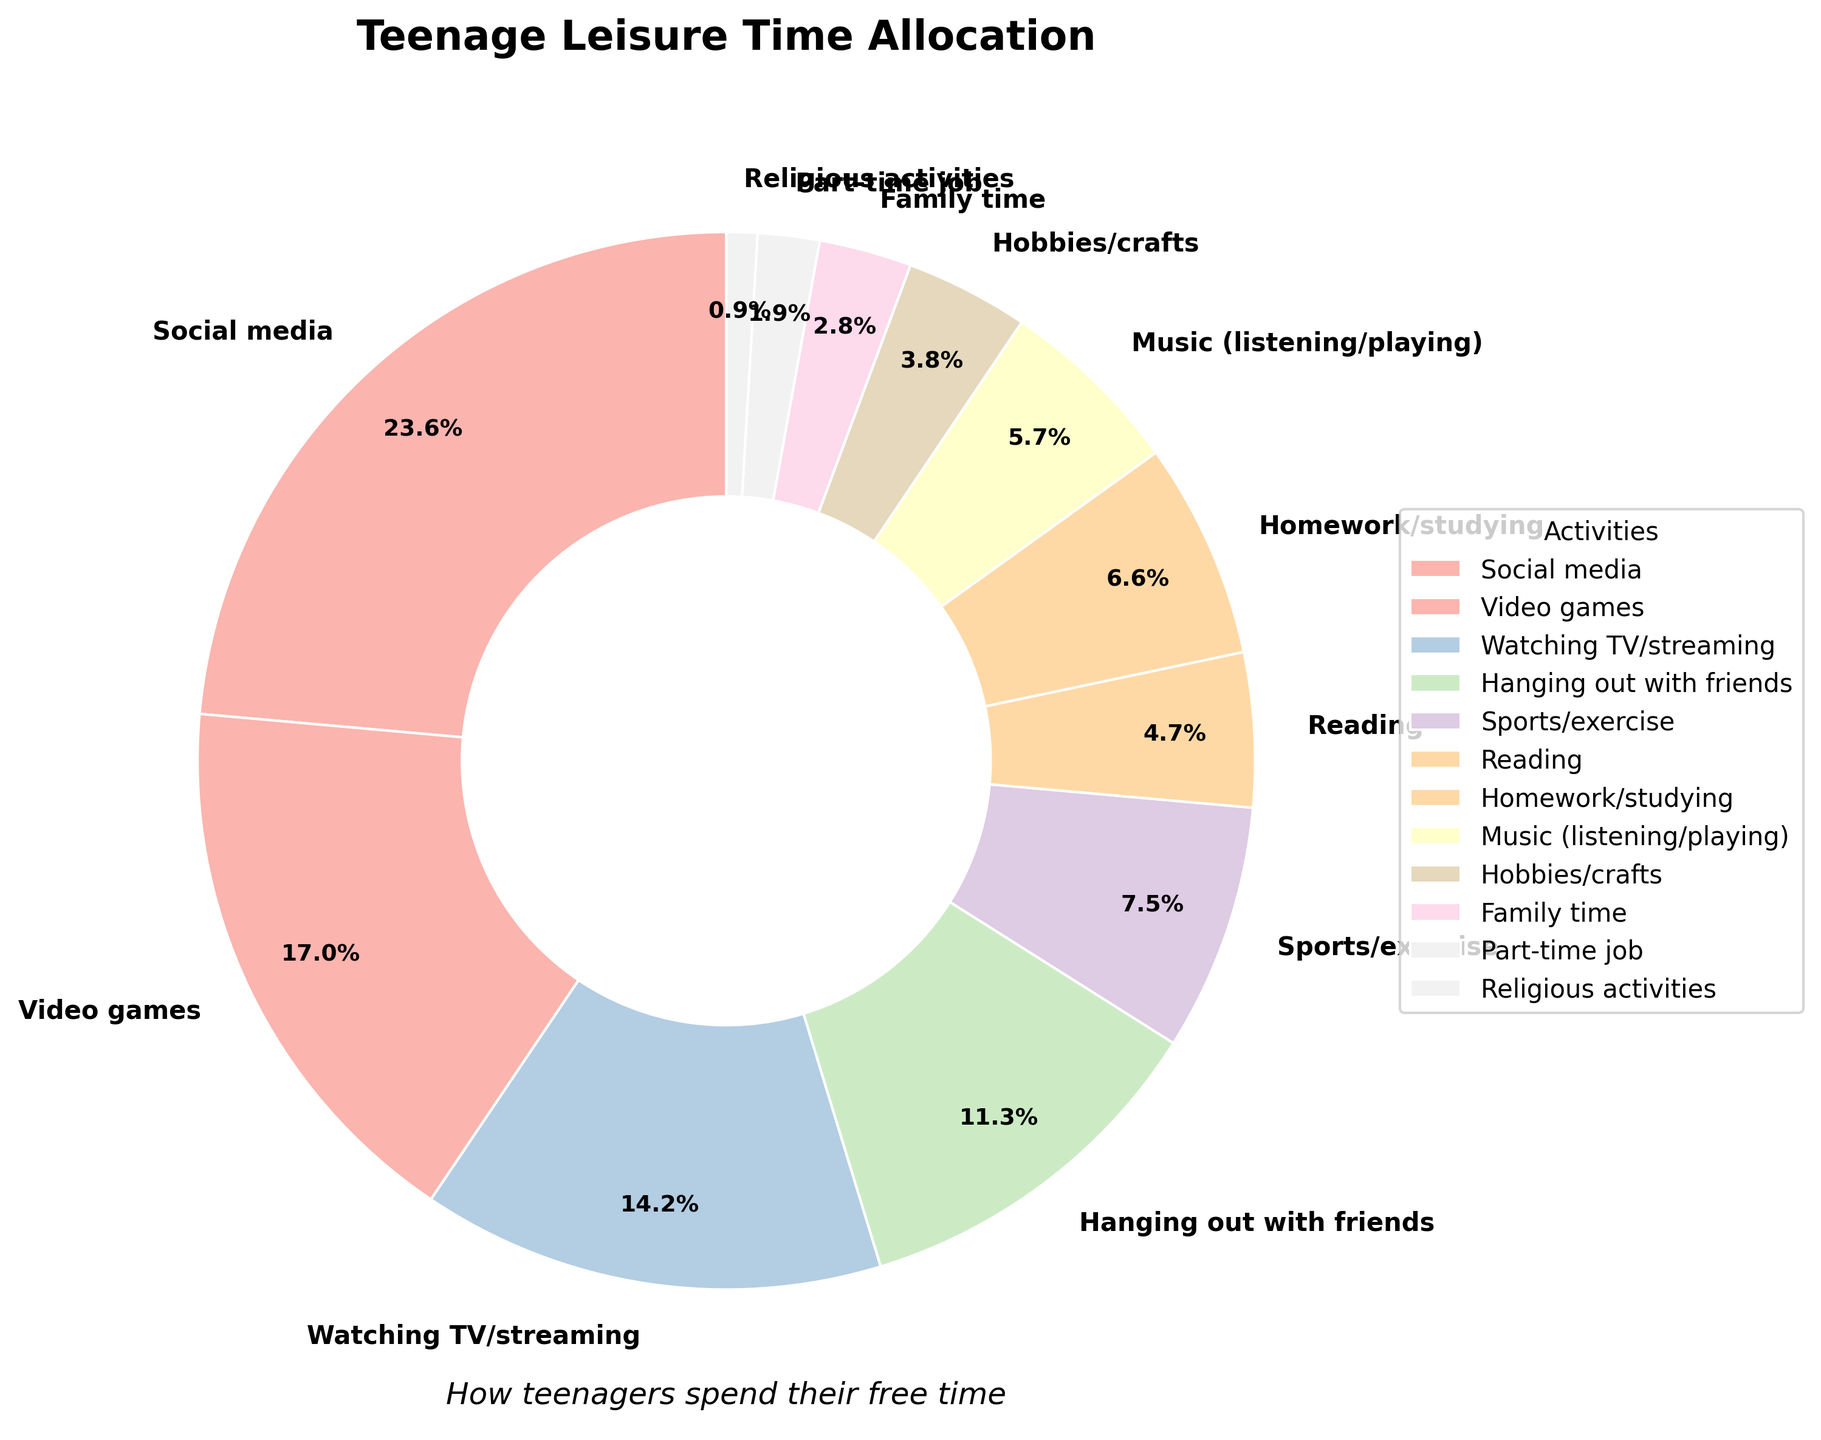What activity occupies the largest percentage of teenage leisure time? By observing the pie chart, the activity with the largest wedge represents the largest percentage. The largest wedge is labeled as “Social media” with a percentage of 25%.
Answer: Social media What is the combined percentage of time spent on social media and video games? The pie chart shows 25% for social media and 18% for video games. Adding these percentages together: 25% + 18% = 43%.
Answer: 43% Which activity has a smaller percentage of teenage leisure time, reading or family time? By comparing the wedges labeled "Reading" and "Family time" in the pie chart, reading is 5% while family time is 3%. Therefore, family time has a smaller percentage.
Answer: Family time What is the difference in percentage of time spent on sports/exercise and on hanging out with friends? The pie chart shows sports/exercise at 8% and hanging out with friends at 12%. The difference is calculated as 12% - 8% = 4%.
Answer: 4% Looking at the pie chart, which activity occupies exactly 5% of teenage leisure time? By examining each labeled wedge, the wedge labeled “Reading” occupies exactly 5% of teenage leisure time.
Answer: Reading How does the time spent on homework/studying compare to time spent on listening/playing music? The pie chart shows that homework/studying is 7% while listening/playing music is 6%. Therefore, more time is spent on homework/studying compared to music.
Answer: More time on homework/studying What is the total percentage for activities that occupy less than 5% of teenage leisure time each? Activities that are less than 5%: Family time (3%), Part-time job (2%), and Religious activities (1%). Adding these percentages together: 3% + 2% + 1% = 6%.
Answer: 6% What is the most visually dominant color wedge indicating an activity, and which activity does it represent? By examining the chart, the most visually prominent wedge (largest) represents the activity. The "Social media" wedge is the largest and most dominant visually.
Answer: Social media Which category has a higher percentage, watching TV/streaming or hanging out with friends? The pie chart shows that watching TV/streaming is 15%, while hanging out with friends is 12%. Watching TV/streaming has a higher percentage.
Answer: Watching TV/streaming 